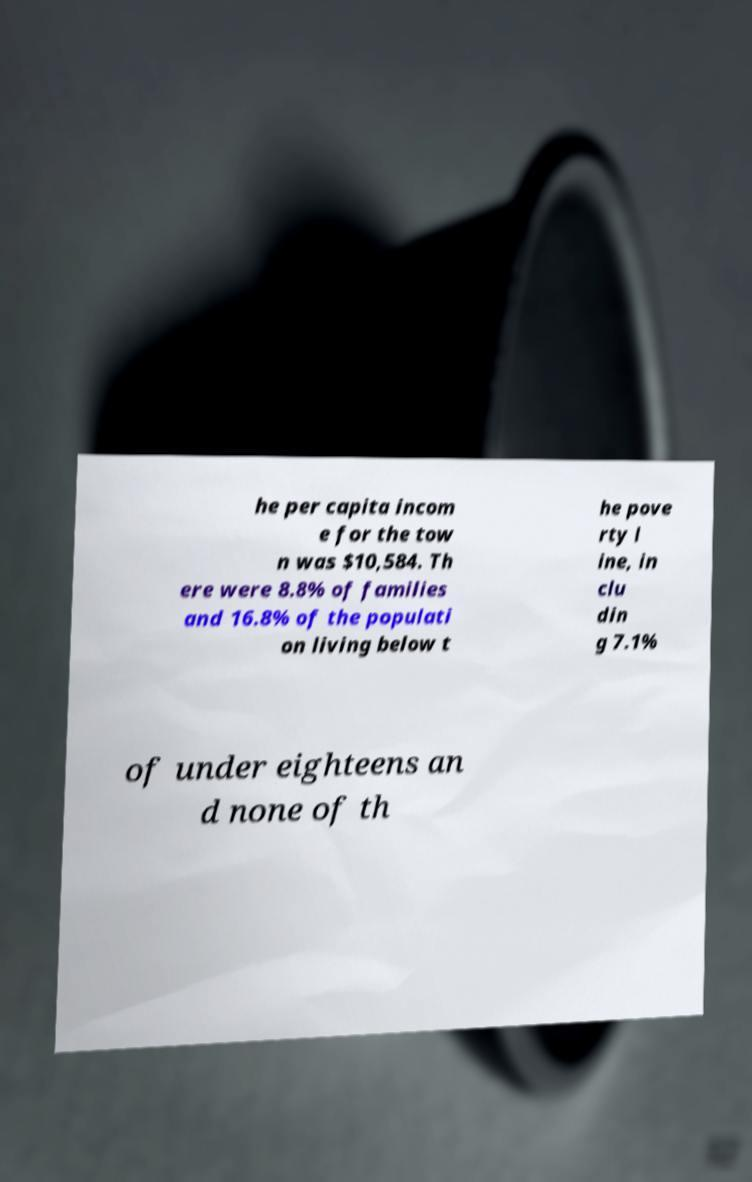Can you accurately transcribe the text from the provided image for me? he per capita incom e for the tow n was $10,584. Th ere were 8.8% of families and 16.8% of the populati on living below t he pove rty l ine, in clu din g 7.1% of under eighteens an d none of th 